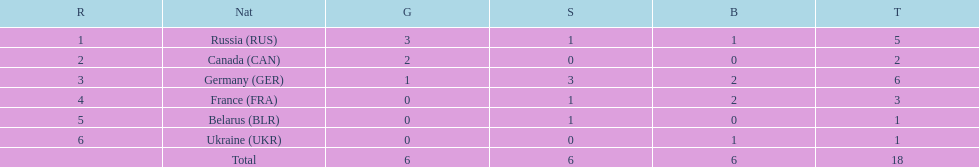Which country won more total medals than tue french, but less than the germans in the 1994 winter olympic biathlon? Russia. Can you give me this table as a dict? {'header': ['R', 'Nat', 'G', 'S', 'B', 'T'], 'rows': [['1', 'Russia\xa0(RUS)', '3', '1', '1', '5'], ['2', 'Canada\xa0(CAN)', '2', '0', '0', '2'], ['3', 'Germany\xa0(GER)', '1', '3', '2', '6'], ['4', 'France\xa0(FRA)', '0', '1', '2', '3'], ['5', 'Belarus\xa0(BLR)', '0', '1', '0', '1'], ['6', 'Ukraine\xa0(UKR)', '0', '0', '1', '1'], ['', 'Total', '6', '6', '6', '18']]} 